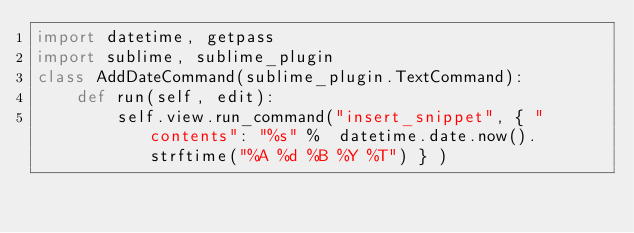<code> <loc_0><loc_0><loc_500><loc_500><_Python_>import datetime, getpass
import sublime, sublime_plugin
class AddDateCommand(sublime_plugin.TextCommand):
    def run(self, edit):
        self.view.run_command("insert_snippet", { "contents": "%s" %  datetime.date.now().strftime("%A %d %B %Y %T") } )
</code> 